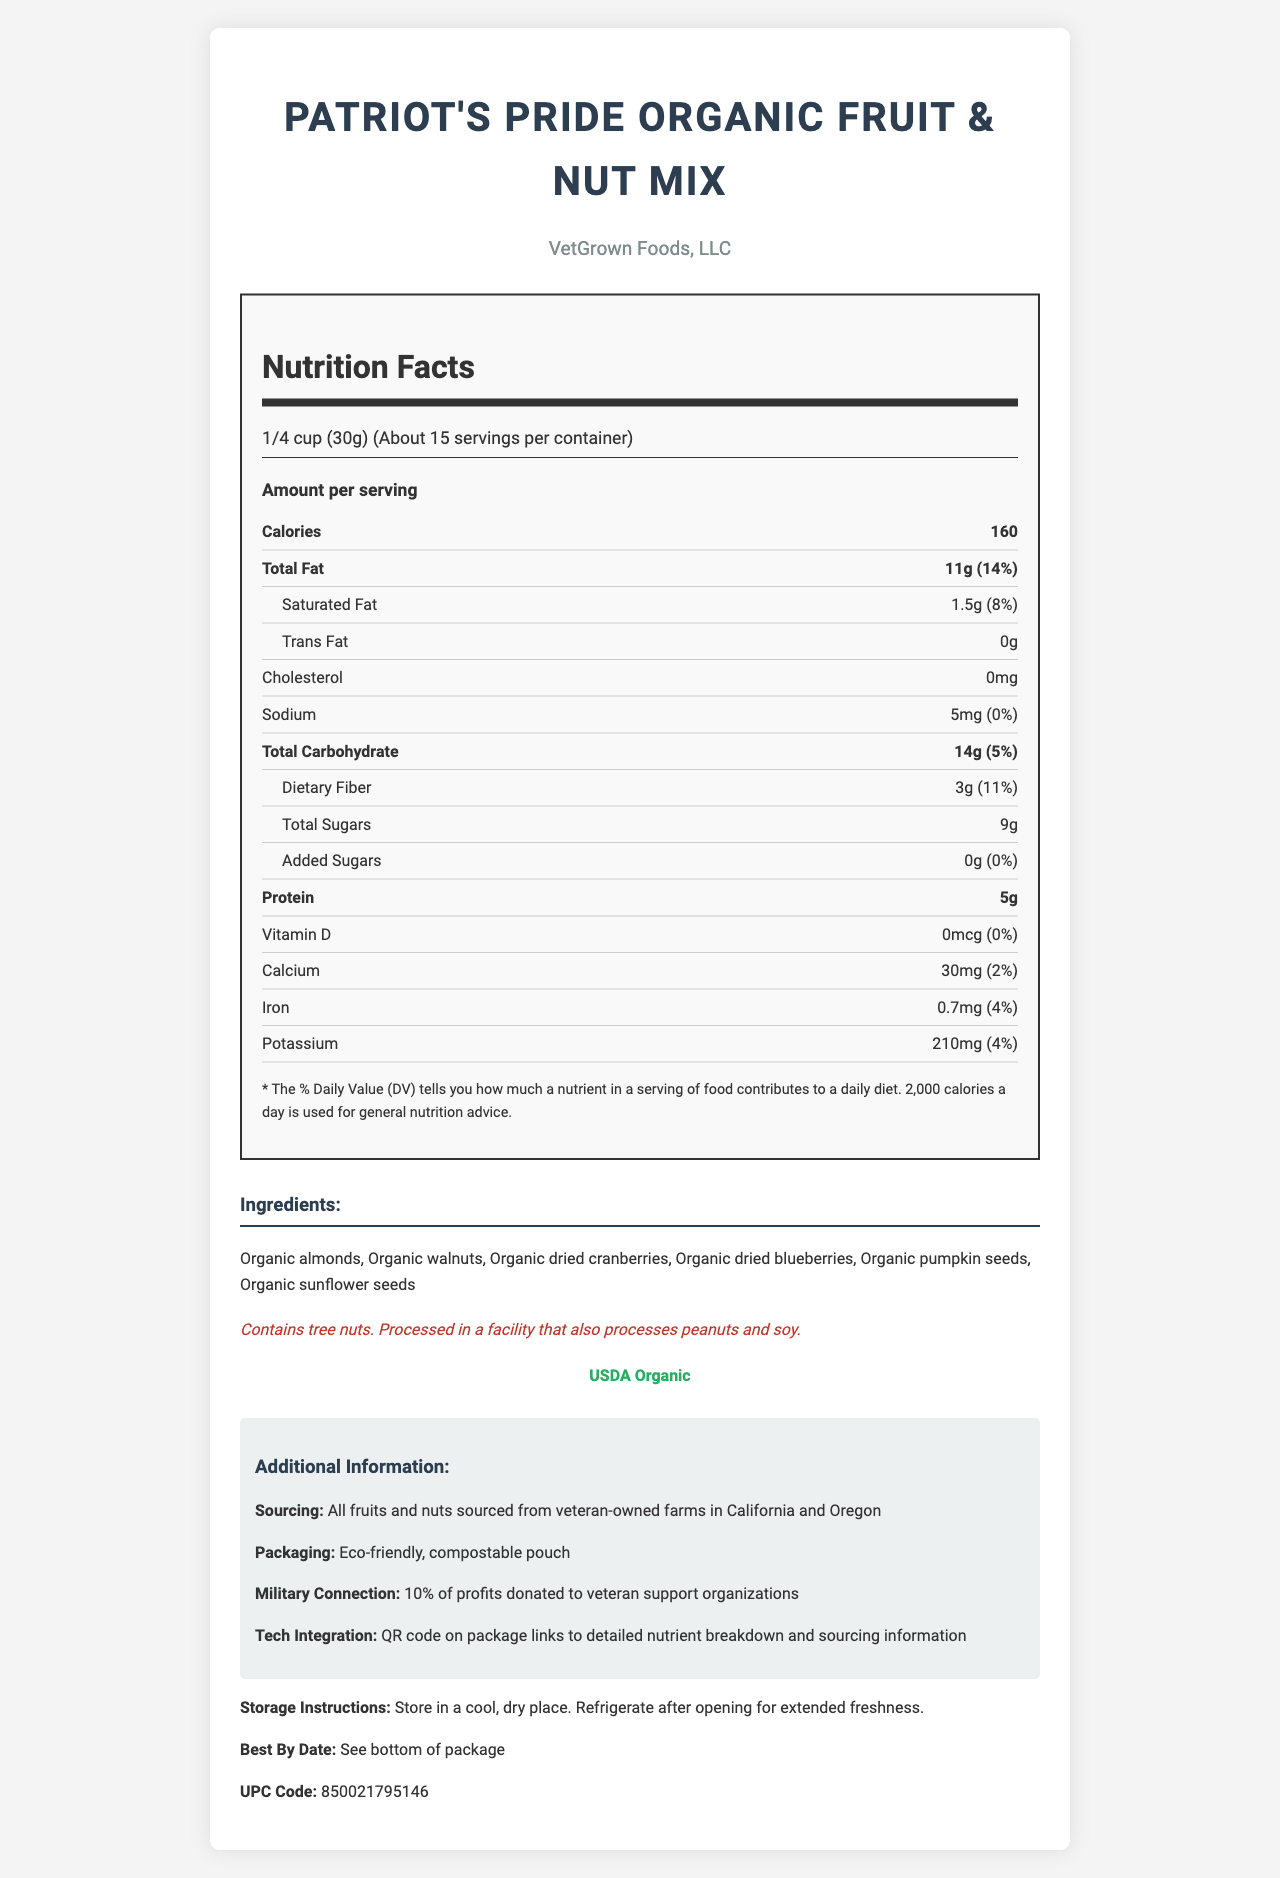what is the serving size of the product? The serving size information is explicitly mentioned at the top of the nutrition facts section.
Answer: 1/4 cup (30g) how many servings are there per container? This information is given in the serving info part of the nutrition facts.
Answer: About 15 what are the total calories per serving? The calories per serving is prominently displayed in the nutrition facts as a bold item.
Answer: 160 how much protein is in one serving? This value can be found in the nutrition facts section under the protein nutrient row.
Answer: 5g what is the amount of dietary fiber per serving? This detail is specified in the nutrition facts under the dietary fiber row.
Answer: 3g what is the daily value percentage of total fat per serving? This percentage is listed next to the total fat amount in the nutrition facts section.
Answer: 14% which of the following is not included in the ingredients? A. Organic walnuts B. Organic cashews C. Organic dried cranberries D. Organic pumpkin seeds Organic cashews are not listed in the ingredients. The ingredients include organic walnuts, organic dried cranberries, and organic pumpkin seeds.
Answer: B what is the amount of calcium in one serving? This value is listed in the nutrient row for calcium in the nutrition facts section.
Answer: 30mg how is the packaging described? A. Recyclable plastic B. Eco-friendly cardboard C. Compostable pouch The packaging is described as an eco-friendly, compostable pouch in the additional information section.
Answer: C does the product contain any added sugars? The added sugars row in the nutrition facts states that there are 0g of added sugars and 0% daily value.
Answer: No is there any cholesterol in the product? The cholesterol amount is listed as 0mg in the nutrition facts section.
Answer: No describe the military connection of the product and company The military connection is detailed in the additional information section, which states that 10% of profits are donated to veteran support organizations, and all ingredients are sourced from veteran-owned farms.
Answer: 10% of profits donated to veteran support organizations. The company is veteran-owned and sources ingredients from veteran-owned farms. summarize the entire document Summarizing the document includes mentioning the nutrition facts, ingredients, allergen information, certification, and additional details about sourcing, packaging, military connection, and storage instructions.
Answer: The document provides the nutrition facts, ingredients, allergen information, certification, and additional information for "Patriot's Pride Organic Fruit & Nut Mix" produced by VetGrown Foods, LLC, a veteran-owned business. It includes detailed nutrient information, sourcing from veteran-owned farms, eco-friendly packaging, and a military connection with profits supporting veteran organizations. what is the sodium amount per serving? The sodium amount is listed in the nutrition facts section as 5mg.
Answer: 5mg what is the best by date? The best by date instruction is given at the end of the document.
Answer: See bottom of package how much vitamin D is in each serving? The vitamin D amount is shown as 0mcg in the nutrition facts section.
Answer: 0mcg where are the fruits and nuts sourced from? The sourcing information in the additional details specifies that fruits and nuts are sourced from veteran-owned farms in California and Oregon.
Answer: California and Oregon veteran-owned farms what is the company that produces this product? This information is clearly mentioned at the beginning of the document under the company name section.
Answer: VetGrown Foods, LLC can you tell me the price of the product? The document does not provide any information regarding the price of the product.
Answer: Cannot be determined 